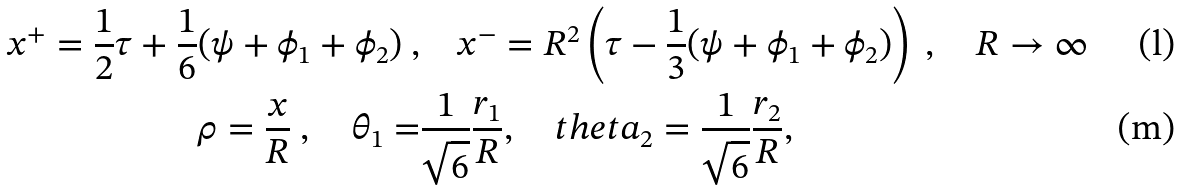Convert formula to latex. <formula><loc_0><loc_0><loc_500><loc_500>x ^ { + } = \frac { 1 } { 2 } \tau + \frac { 1 } { 6 } ( \psi + \phi _ { 1 } + \phi _ { 2 } ) \ , & \quad x ^ { - } = { R ^ { 2 } } \left ( \tau - \frac { 1 } { 3 } ( \psi + \phi _ { 1 } + \phi _ { 2 } ) \right ) \ , \quad R \to \infty \\ \rho = \frac { x } { R } \ , \quad \theta _ { 1 } = & \frac { 1 } { \sqrt { 6 } } \frac { r _ { 1 } } { R } , \quad t h e t a _ { 2 } = \frac { 1 } { \sqrt { 6 } } \frac { r _ { 2 } } { R } ,</formula> 